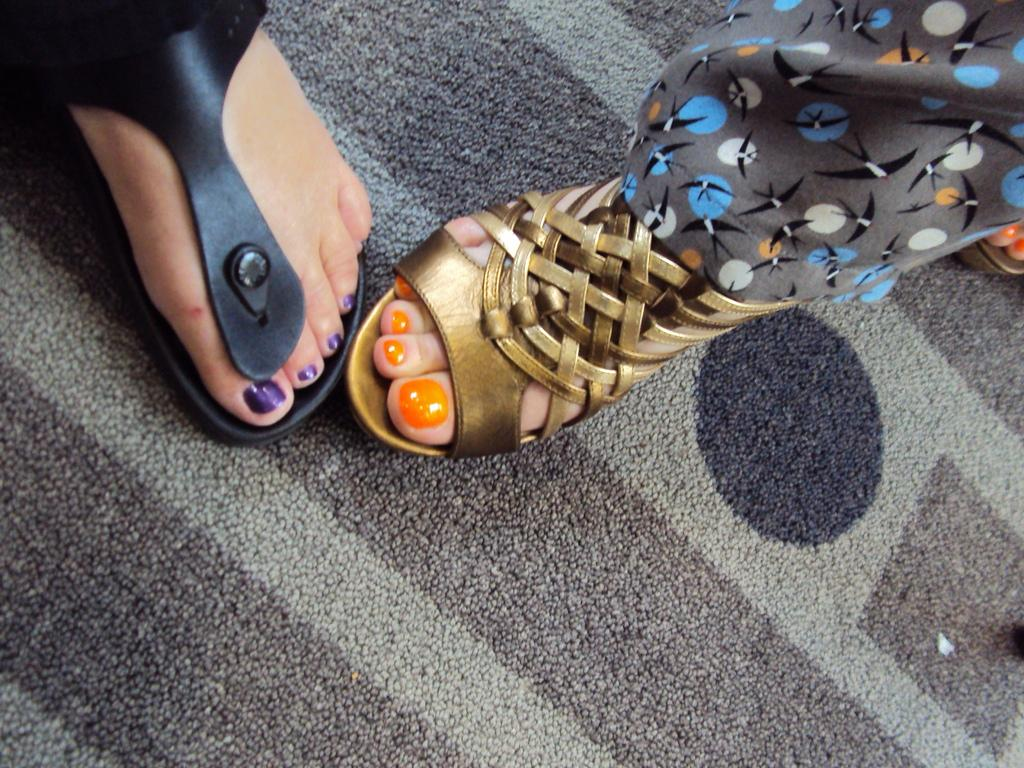How many legs can be seen on the carpet in the image? There are three legs on the carpet in the image. What type of footwear is the person on the left side wearing? The person on the left side is wearing a black sandal. What type of footwear is the person on the right side wearing? The person on the right side is wearing a golden sandal. What type of quilt is being used as a tablecloth in the image? There is no quilt present in the image, nor is there a tablecloth. What type of meal is being prepared on the carpet in the image? There is no meal preparation visible in the image. 